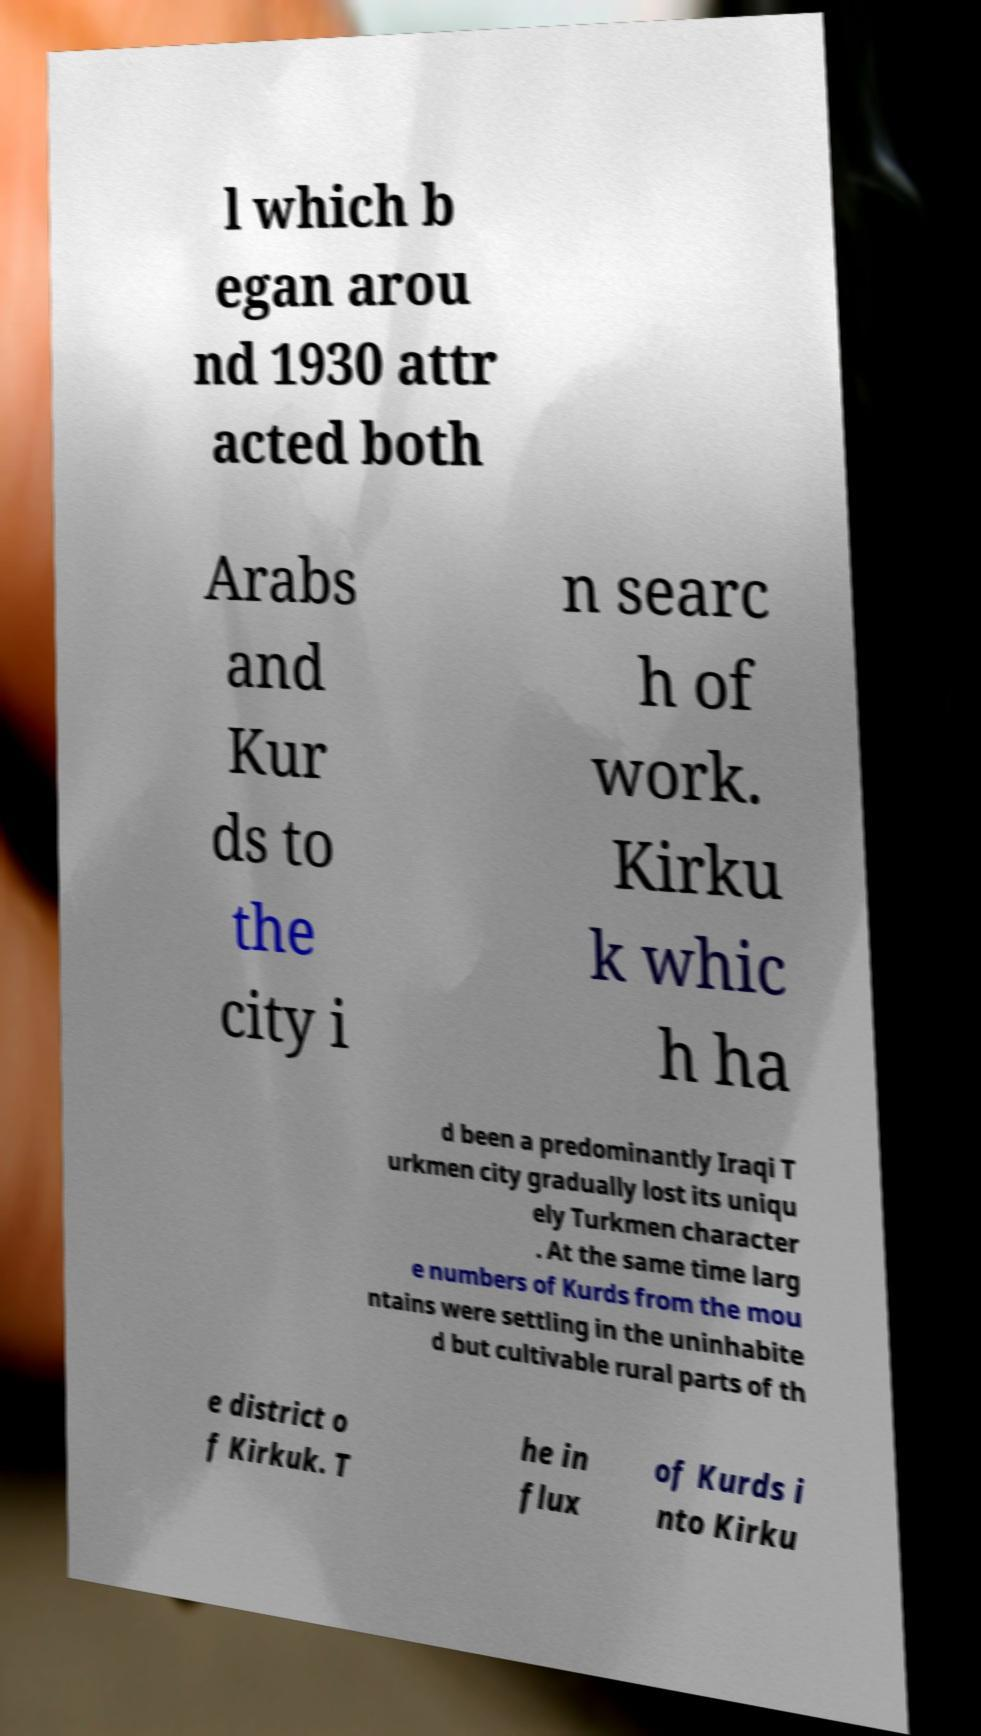Please read and relay the text visible in this image. What does it say? l which b egan arou nd 1930 attr acted both Arabs and Kur ds to the city i n searc h of work. Kirku k whic h ha d been a predominantly Iraqi T urkmen city gradually lost its uniqu ely Turkmen character . At the same time larg e numbers of Kurds from the mou ntains were settling in the uninhabite d but cultivable rural parts of th e district o f Kirkuk. T he in flux of Kurds i nto Kirku 